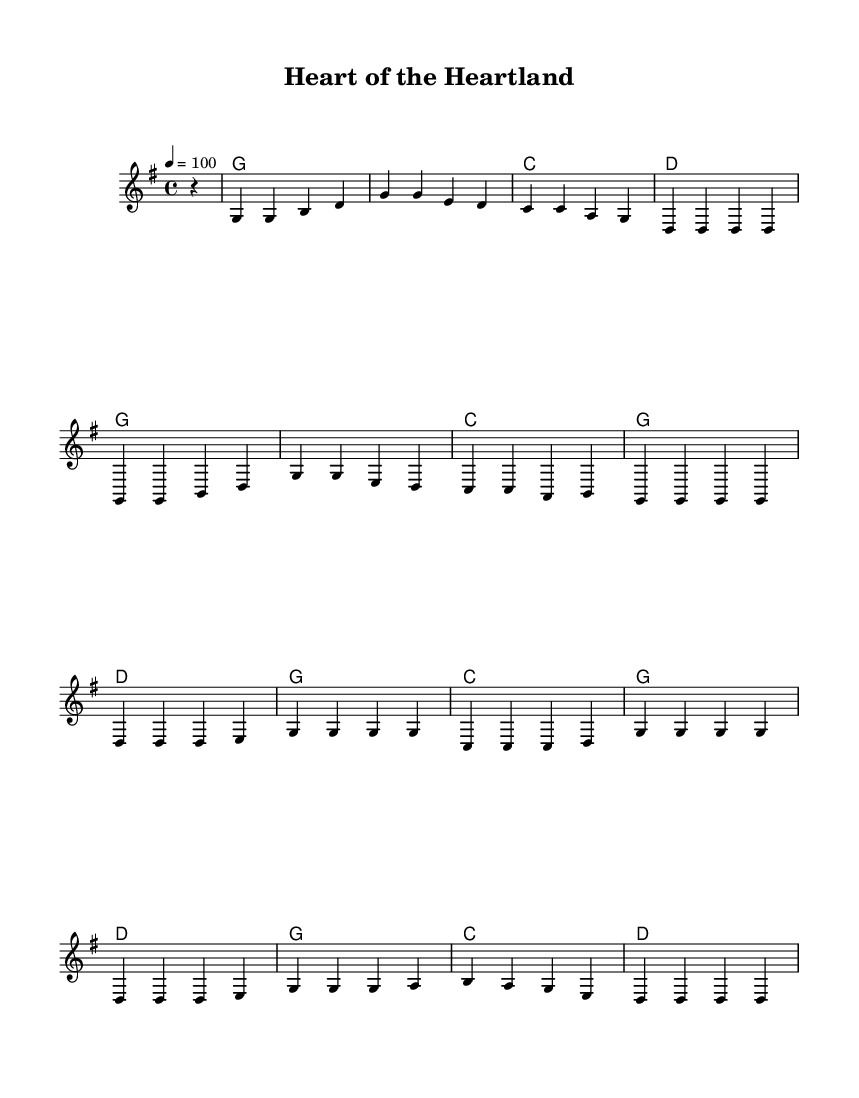What is the key signature of this music? The key signature is indicated at the beginning of the piece, which shows one sharp, corresponding to the G major scale.
Answer: G major What is the time signature of this music? The time signature is found at the beginning, indicating that there are four beats in each measure, specifically marked as 4/4.
Answer: 4/4 What is the tempo marking for the music? The tempo marking is stated as '4 = 100', meaning there are 100 beats per minute, setting the pace for the piece.
Answer: 100 How many measures are in the verse section? Counting the measures in the verse as indicated in the score, there are a total of 8 measures (four phrases of two measures each).
Answer: 8 What is the primary chord progression used in the verse? Analyzing the harmonies listed for the verse, the chords change as follows: G, G, C, D, G, G, C, G, indicating a straightforward country rock progression.
Answer: G, C, D How many times is the chorus repeated? By inspecting the structure of the piece, the chorus is repeated twice in the arrangement, as shown by its placement in the score.
Answer: 2 What musical style does this piece represent? This piece exemplifies the characteristics of country rock, evident in its blending of country melodies with rock rhythms and instrumentation.
Answer: Country rock 